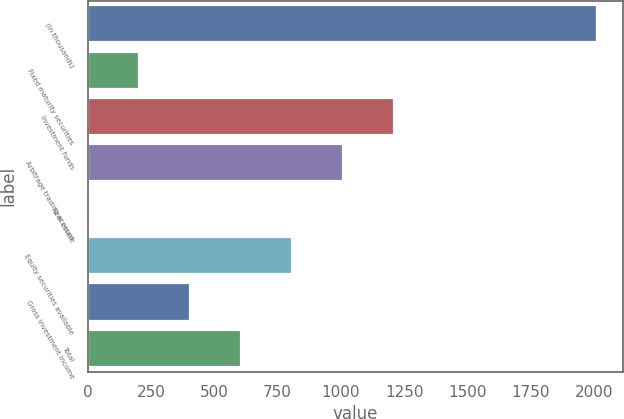Convert chart to OTSL. <chart><loc_0><loc_0><loc_500><loc_500><bar_chart><fcel>(In thousands)<fcel>Fixed maturity securities<fcel>Investment funds<fcel>Arbitrage trading account<fcel>Real estate<fcel>Equity securities available<fcel>Gross investment income<fcel>Total<nl><fcel>2013<fcel>203.1<fcel>1208.6<fcel>1007.5<fcel>2<fcel>806.4<fcel>404.2<fcel>605.3<nl></chart> 